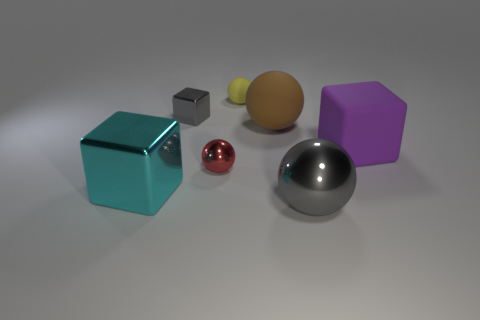Add 1 big cyan things. How many objects exist? 8 Subtract 0 cyan cylinders. How many objects are left? 7 Subtract all cubes. How many objects are left? 4 Subtract 1 cubes. How many cubes are left? 2 Subtract all yellow balls. Subtract all brown cylinders. How many balls are left? 3 Subtract all gray blocks. How many blue spheres are left? 0 Subtract all rubber things. Subtract all purple rubber things. How many objects are left? 3 Add 5 small yellow objects. How many small yellow objects are left? 6 Add 5 red matte cylinders. How many red matte cylinders exist? 5 Subtract all cyan cubes. How many cubes are left? 2 